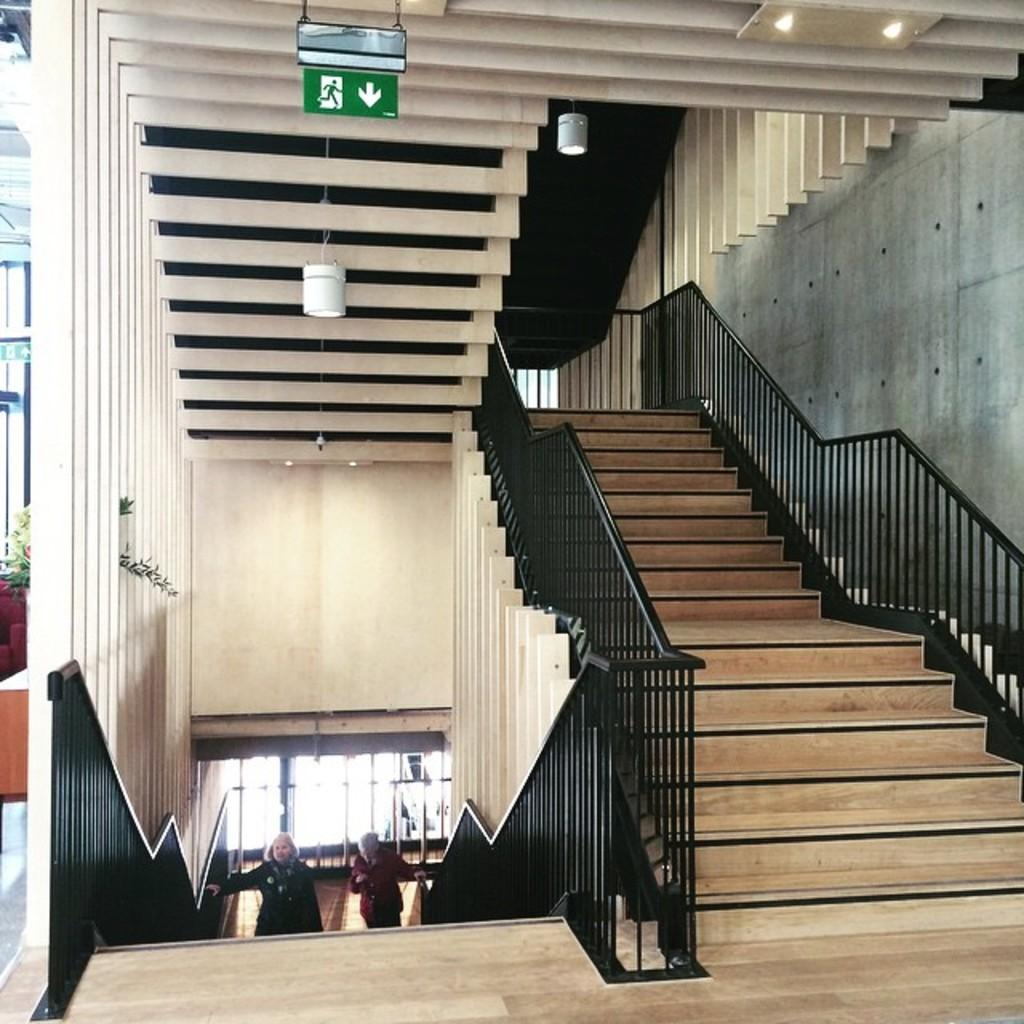What type of structure is present in the image? There are stairs in the image. What can be seen on the wall in the image? There is a white color wall in the image. Are there any plants visible in the image? Yes, there is a plant in the image. How many people are present in the image? There are two people in the image. Can you tell me how many mice are running around the plant in the image? There are no mice present in the image; it only features a plant, stairs, a white wall, and two people. 